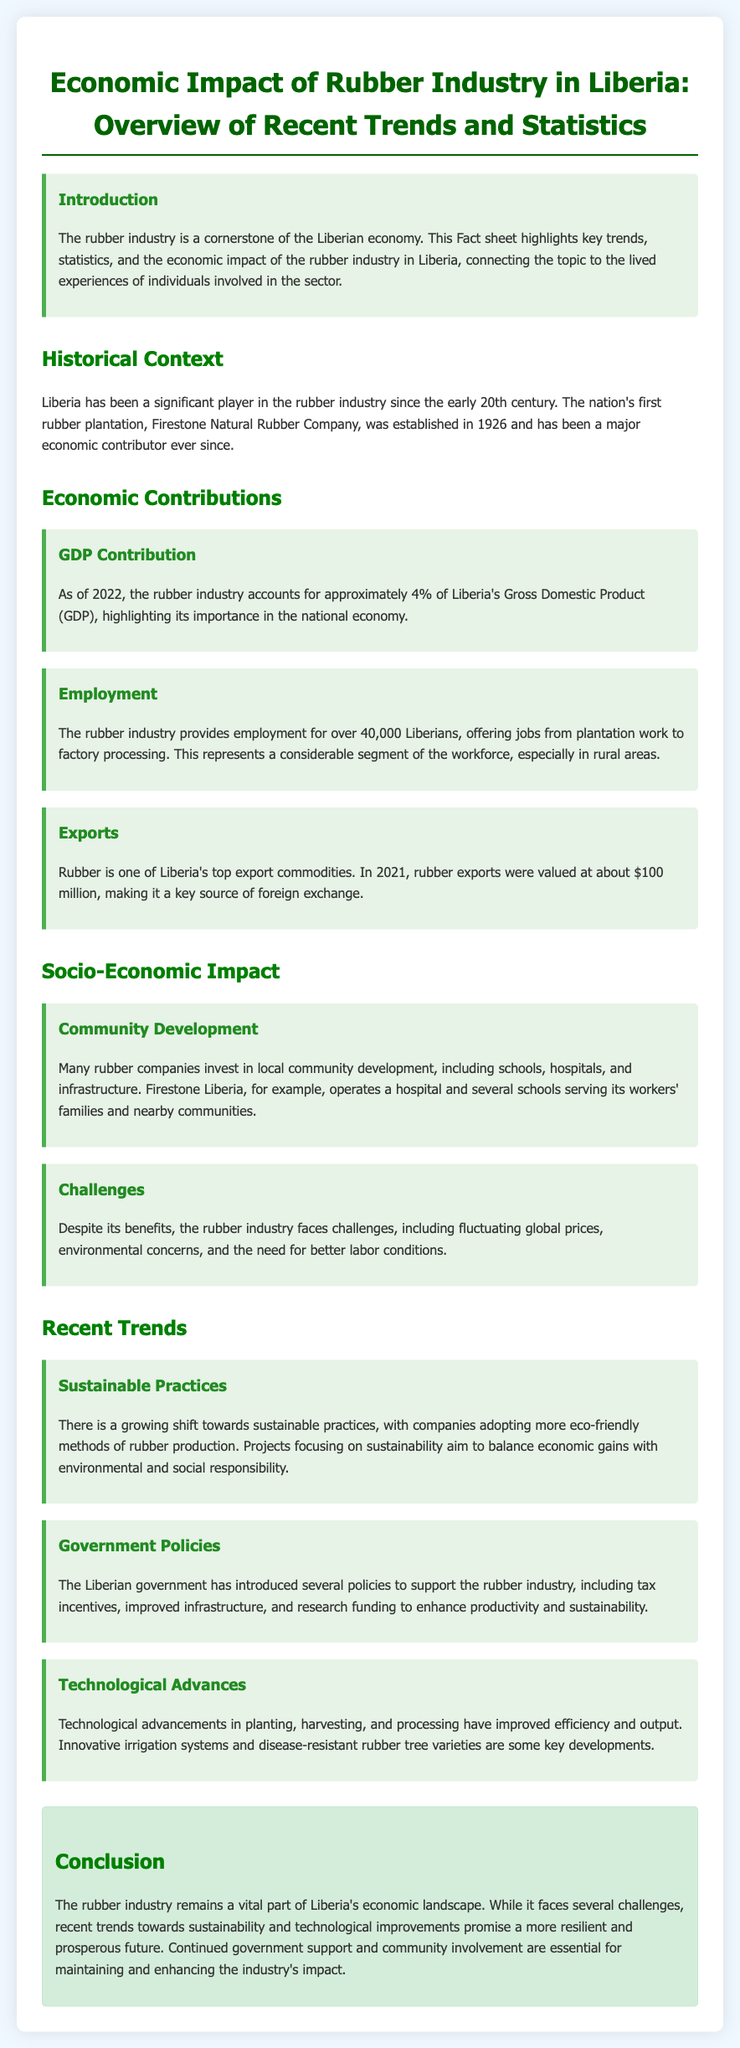What is the contribution of the rubber industry to Liberia's GDP? The document states that the rubber industry accounts for approximately 4% of Liberia's Gross Domestic Product (GDP).
Answer: 4% How many Liberians are employed by the rubber industry? The document mentions that the rubber industry provides employment for over 40,000 Liberians.
Answer: Over 40,000 What was the value of rubber exports in 2021? The fact sheet indicates that rubber exports were valued at about $100 million in 2021.
Answer: $100 million What company established the first rubber plantation in Liberia? The historical context section states that the first rubber plantation, Firestone Natural Rubber Company, was established in 1926.
Answer: Firestone Natural Rubber Company What is a significant challenge mentioned for the rubber industry? The document points out fluctuating global prices as one of the challenges faced by the rubber industry.
Answer: Fluctuating global prices What type of practices are being adopted in the rubber industry? The document highlights that there is a growing shift towards sustainable practices in rubber production.
Answer: Sustainable practices What has the Liberian government introduced to support the rubber industry? The document mentions that the government has introduced tax incentives to support the rubber industry.
Answer: Tax incentives What community development efforts are mentioned in the document? It states that many rubber companies invest in local community development, including schools and hospitals.
Answer: Schools and hospitals What role do technological advancements play in the rubber industry? The document explains that technological advancements have improved efficiency and output in rubber production.
Answer: Improved efficiency and output 